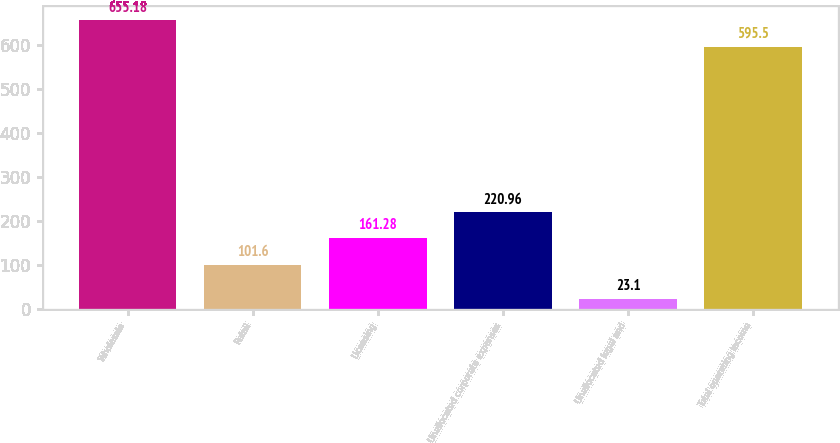<chart> <loc_0><loc_0><loc_500><loc_500><bar_chart><fcel>Wholesale<fcel>Retail<fcel>Licensing<fcel>Unallocated corporate expenses<fcel>Unallocated legal and<fcel>Total operating income<nl><fcel>655.18<fcel>101.6<fcel>161.28<fcel>220.96<fcel>23.1<fcel>595.5<nl></chart> 